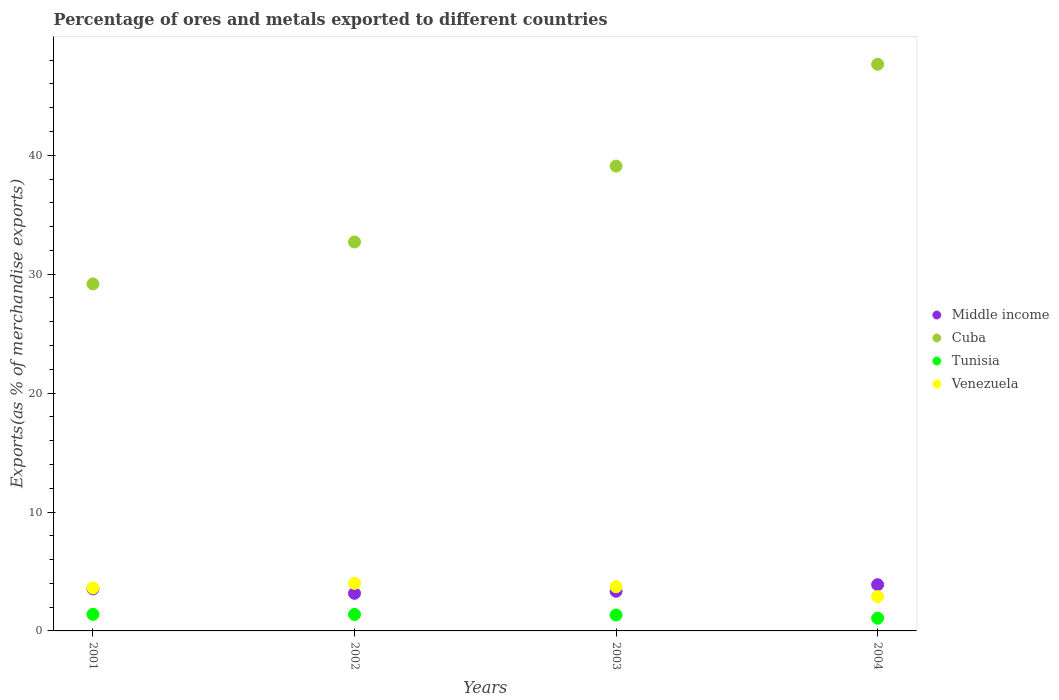How many different coloured dotlines are there?
Keep it short and to the point. 4. What is the percentage of exports to different countries in Middle income in 2001?
Offer a very short reply. 3.53. Across all years, what is the maximum percentage of exports to different countries in Cuba?
Ensure brevity in your answer.  47.66. Across all years, what is the minimum percentage of exports to different countries in Cuba?
Your response must be concise. 29.18. In which year was the percentage of exports to different countries in Tunisia maximum?
Your answer should be compact. 2001. What is the total percentage of exports to different countries in Venezuela in the graph?
Provide a succinct answer. 14.22. What is the difference between the percentage of exports to different countries in Middle income in 2002 and that in 2003?
Your answer should be very brief. -0.17. What is the difference between the percentage of exports to different countries in Cuba in 2002 and the percentage of exports to different countries in Tunisia in 2001?
Give a very brief answer. 31.32. What is the average percentage of exports to different countries in Venezuela per year?
Provide a succinct answer. 3.55. In the year 2003, what is the difference between the percentage of exports to different countries in Cuba and percentage of exports to different countries in Tunisia?
Offer a very short reply. 37.75. In how many years, is the percentage of exports to different countries in Middle income greater than 12 %?
Keep it short and to the point. 0. What is the ratio of the percentage of exports to different countries in Tunisia in 2001 to that in 2004?
Make the answer very short. 1.3. Is the difference between the percentage of exports to different countries in Cuba in 2001 and 2003 greater than the difference between the percentage of exports to different countries in Tunisia in 2001 and 2003?
Provide a short and direct response. No. What is the difference between the highest and the second highest percentage of exports to different countries in Cuba?
Keep it short and to the point. 8.56. What is the difference between the highest and the lowest percentage of exports to different countries in Venezuela?
Your answer should be compact. 1.11. In how many years, is the percentage of exports to different countries in Tunisia greater than the average percentage of exports to different countries in Tunisia taken over all years?
Your answer should be compact. 3. Is the percentage of exports to different countries in Cuba strictly greater than the percentage of exports to different countries in Tunisia over the years?
Offer a very short reply. Yes. Is the percentage of exports to different countries in Cuba strictly less than the percentage of exports to different countries in Middle income over the years?
Provide a succinct answer. No. How many dotlines are there?
Provide a succinct answer. 4. How many years are there in the graph?
Give a very brief answer. 4. Are the values on the major ticks of Y-axis written in scientific E-notation?
Provide a succinct answer. No. Does the graph contain grids?
Keep it short and to the point. No. Where does the legend appear in the graph?
Make the answer very short. Center right. How are the legend labels stacked?
Offer a very short reply. Vertical. What is the title of the graph?
Provide a short and direct response. Percentage of ores and metals exported to different countries. What is the label or title of the X-axis?
Ensure brevity in your answer.  Years. What is the label or title of the Y-axis?
Your answer should be very brief. Exports(as % of merchandise exports). What is the Exports(as % of merchandise exports) of Middle income in 2001?
Your answer should be compact. 3.53. What is the Exports(as % of merchandise exports) in Cuba in 2001?
Offer a very short reply. 29.18. What is the Exports(as % of merchandise exports) of Tunisia in 2001?
Ensure brevity in your answer.  1.39. What is the Exports(as % of merchandise exports) of Venezuela in 2001?
Keep it short and to the point. 3.61. What is the Exports(as % of merchandise exports) in Middle income in 2002?
Give a very brief answer. 3.16. What is the Exports(as % of merchandise exports) in Cuba in 2002?
Offer a terse response. 32.71. What is the Exports(as % of merchandise exports) in Tunisia in 2002?
Provide a short and direct response. 1.39. What is the Exports(as % of merchandise exports) of Venezuela in 2002?
Give a very brief answer. 4. What is the Exports(as % of merchandise exports) of Middle income in 2003?
Ensure brevity in your answer.  3.33. What is the Exports(as % of merchandise exports) in Cuba in 2003?
Your response must be concise. 39.09. What is the Exports(as % of merchandise exports) in Tunisia in 2003?
Your response must be concise. 1.34. What is the Exports(as % of merchandise exports) in Venezuela in 2003?
Keep it short and to the point. 3.72. What is the Exports(as % of merchandise exports) in Middle income in 2004?
Your answer should be compact. 3.89. What is the Exports(as % of merchandise exports) of Cuba in 2004?
Keep it short and to the point. 47.66. What is the Exports(as % of merchandise exports) in Tunisia in 2004?
Ensure brevity in your answer.  1.07. What is the Exports(as % of merchandise exports) of Venezuela in 2004?
Offer a very short reply. 2.89. Across all years, what is the maximum Exports(as % of merchandise exports) of Middle income?
Your answer should be compact. 3.89. Across all years, what is the maximum Exports(as % of merchandise exports) of Cuba?
Your answer should be compact. 47.66. Across all years, what is the maximum Exports(as % of merchandise exports) in Tunisia?
Your response must be concise. 1.39. Across all years, what is the maximum Exports(as % of merchandise exports) of Venezuela?
Provide a succinct answer. 4. Across all years, what is the minimum Exports(as % of merchandise exports) of Middle income?
Your answer should be very brief. 3.16. Across all years, what is the minimum Exports(as % of merchandise exports) in Cuba?
Provide a short and direct response. 29.18. Across all years, what is the minimum Exports(as % of merchandise exports) of Tunisia?
Offer a terse response. 1.07. Across all years, what is the minimum Exports(as % of merchandise exports) in Venezuela?
Provide a succinct answer. 2.89. What is the total Exports(as % of merchandise exports) of Middle income in the graph?
Keep it short and to the point. 13.92. What is the total Exports(as % of merchandise exports) in Cuba in the graph?
Provide a succinct answer. 148.64. What is the total Exports(as % of merchandise exports) in Tunisia in the graph?
Give a very brief answer. 5.19. What is the total Exports(as % of merchandise exports) in Venezuela in the graph?
Make the answer very short. 14.22. What is the difference between the Exports(as % of merchandise exports) in Middle income in 2001 and that in 2002?
Give a very brief answer. 0.37. What is the difference between the Exports(as % of merchandise exports) in Cuba in 2001 and that in 2002?
Make the answer very short. -3.53. What is the difference between the Exports(as % of merchandise exports) in Tunisia in 2001 and that in 2002?
Provide a short and direct response. 0.01. What is the difference between the Exports(as % of merchandise exports) of Venezuela in 2001 and that in 2002?
Ensure brevity in your answer.  -0.39. What is the difference between the Exports(as % of merchandise exports) of Middle income in 2001 and that in 2003?
Offer a very short reply. 0.2. What is the difference between the Exports(as % of merchandise exports) in Cuba in 2001 and that in 2003?
Your response must be concise. -9.91. What is the difference between the Exports(as % of merchandise exports) of Tunisia in 2001 and that in 2003?
Offer a very short reply. 0.06. What is the difference between the Exports(as % of merchandise exports) in Venezuela in 2001 and that in 2003?
Make the answer very short. -0.1. What is the difference between the Exports(as % of merchandise exports) of Middle income in 2001 and that in 2004?
Your response must be concise. -0.36. What is the difference between the Exports(as % of merchandise exports) in Cuba in 2001 and that in 2004?
Give a very brief answer. -18.47. What is the difference between the Exports(as % of merchandise exports) in Tunisia in 2001 and that in 2004?
Provide a short and direct response. 0.32. What is the difference between the Exports(as % of merchandise exports) of Venezuela in 2001 and that in 2004?
Provide a short and direct response. 0.73. What is the difference between the Exports(as % of merchandise exports) of Middle income in 2002 and that in 2003?
Offer a very short reply. -0.17. What is the difference between the Exports(as % of merchandise exports) of Cuba in 2002 and that in 2003?
Provide a succinct answer. -6.38. What is the difference between the Exports(as % of merchandise exports) in Tunisia in 2002 and that in 2003?
Make the answer very short. 0.05. What is the difference between the Exports(as % of merchandise exports) of Venezuela in 2002 and that in 2003?
Provide a succinct answer. 0.28. What is the difference between the Exports(as % of merchandise exports) of Middle income in 2002 and that in 2004?
Keep it short and to the point. -0.73. What is the difference between the Exports(as % of merchandise exports) of Cuba in 2002 and that in 2004?
Ensure brevity in your answer.  -14.95. What is the difference between the Exports(as % of merchandise exports) in Tunisia in 2002 and that in 2004?
Keep it short and to the point. 0.32. What is the difference between the Exports(as % of merchandise exports) in Venezuela in 2002 and that in 2004?
Ensure brevity in your answer.  1.11. What is the difference between the Exports(as % of merchandise exports) in Middle income in 2003 and that in 2004?
Give a very brief answer. -0.56. What is the difference between the Exports(as % of merchandise exports) of Cuba in 2003 and that in 2004?
Ensure brevity in your answer.  -8.56. What is the difference between the Exports(as % of merchandise exports) of Tunisia in 2003 and that in 2004?
Your answer should be compact. 0.27. What is the difference between the Exports(as % of merchandise exports) in Venezuela in 2003 and that in 2004?
Make the answer very short. 0.83. What is the difference between the Exports(as % of merchandise exports) in Middle income in 2001 and the Exports(as % of merchandise exports) in Cuba in 2002?
Keep it short and to the point. -29.18. What is the difference between the Exports(as % of merchandise exports) in Middle income in 2001 and the Exports(as % of merchandise exports) in Tunisia in 2002?
Your response must be concise. 2.15. What is the difference between the Exports(as % of merchandise exports) of Middle income in 2001 and the Exports(as % of merchandise exports) of Venezuela in 2002?
Provide a succinct answer. -0.47. What is the difference between the Exports(as % of merchandise exports) in Cuba in 2001 and the Exports(as % of merchandise exports) in Tunisia in 2002?
Provide a short and direct response. 27.8. What is the difference between the Exports(as % of merchandise exports) of Cuba in 2001 and the Exports(as % of merchandise exports) of Venezuela in 2002?
Offer a very short reply. 25.18. What is the difference between the Exports(as % of merchandise exports) of Tunisia in 2001 and the Exports(as % of merchandise exports) of Venezuela in 2002?
Ensure brevity in your answer.  -2.61. What is the difference between the Exports(as % of merchandise exports) in Middle income in 2001 and the Exports(as % of merchandise exports) in Cuba in 2003?
Offer a very short reply. -35.56. What is the difference between the Exports(as % of merchandise exports) of Middle income in 2001 and the Exports(as % of merchandise exports) of Tunisia in 2003?
Offer a very short reply. 2.19. What is the difference between the Exports(as % of merchandise exports) of Middle income in 2001 and the Exports(as % of merchandise exports) of Venezuela in 2003?
Offer a very short reply. -0.18. What is the difference between the Exports(as % of merchandise exports) in Cuba in 2001 and the Exports(as % of merchandise exports) in Tunisia in 2003?
Your response must be concise. 27.84. What is the difference between the Exports(as % of merchandise exports) of Cuba in 2001 and the Exports(as % of merchandise exports) of Venezuela in 2003?
Give a very brief answer. 25.47. What is the difference between the Exports(as % of merchandise exports) in Tunisia in 2001 and the Exports(as % of merchandise exports) in Venezuela in 2003?
Provide a short and direct response. -2.32. What is the difference between the Exports(as % of merchandise exports) of Middle income in 2001 and the Exports(as % of merchandise exports) of Cuba in 2004?
Offer a terse response. -44.12. What is the difference between the Exports(as % of merchandise exports) in Middle income in 2001 and the Exports(as % of merchandise exports) in Tunisia in 2004?
Provide a short and direct response. 2.46. What is the difference between the Exports(as % of merchandise exports) in Middle income in 2001 and the Exports(as % of merchandise exports) in Venezuela in 2004?
Offer a terse response. 0.65. What is the difference between the Exports(as % of merchandise exports) of Cuba in 2001 and the Exports(as % of merchandise exports) of Tunisia in 2004?
Your response must be concise. 28.11. What is the difference between the Exports(as % of merchandise exports) of Cuba in 2001 and the Exports(as % of merchandise exports) of Venezuela in 2004?
Provide a short and direct response. 26.3. What is the difference between the Exports(as % of merchandise exports) in Tunisia in 2001 and the Exports(as % of merchandise exports) in Venezuela in 2004?
Offer a terse response. -1.49. What is the difference between the Exports(as % of merchandise exports) in Middle income in 2002 and the Exports(as % of merchandise exports) in Cuba in 2003?
Your answer should be very brief. -35.93. What is the difference between the Exports(as % of merchandise exports) in Middle income in 2002 and the Exports(as % of merchandise exports) in Tunisia in 2003?
Provide a succinct answer. 1.82. What is the difference between the Exports(as % of merchandise exports) of Middle income in 2002 and the Exports(as % of merchandise exports) of Venezuela in 2003?
Keep it short and to the point. -0.56. What is the difference between the Exports(as % of merchandise exports) in Cuba in 2002 and the Exports(as % of merchandise exports) in Tunisia in 2003?
Ensure brevity in your answer.  31.37. What is the difference between the Exports(as % of merchandise exports) of Cuba in 2002 and the Exports(as % of merchandise exports) of Venezuela in 2003?
Your answer should be very brief. 28.99. What is the difference between the Exports(as % of merchandise exports) in Tunisia in 2002 and the Exports(as % of merchandise exports) in Venezuela in 2003?
Your response must be concise. -2.33. What is the difference between the Exports(as % of merchandise exports) of Middle income in 2002 and the Exports(as % of merchandise exports) of Cuba in 2004?
Offer a terse response. -44.49. What is the difference between the Exports(as % of merchandise exports) in Middle income in 2002 and the Exports(as % of merchandise exports) in Tunisia in 2004?
Offer a very short reply. 2.09. What is the difference between the Exports(as % of merchandise exports) in Middle income in 2002 and the Exports(as % of merchandise exports) in Venezuela in 2004?
Make the answer very short. 0.27. What is the difference between the Exports(as % of merchandise exports) in Cuba in 2002 and the Exports(as % of merchandise exports) in Tunisia in 2004?
Provide a short and direct response. 31.64. What is the difference between the Exports(as % of merchandise exports) in Cuba in 2002 and the Exports(as % of merchandise exports) in Venezuela in 2004?
Your answer should be compact. 29.82. What is the difference between the Exports(as % of merchandise exports) in Tunisia in 2002 and the Exports(as % of merchandise exports) in Venezuela in 2004?
Offer a terse response. -1.5. What is the difference between the Exports(as % of merchandise exports) of Middle income in 2003 and the Exports(as % of merchandise exports) of Cuba in 2004?
Ensure brevity in your answer.  -44.32. What is the difference between the Exports(as % of merchandise exports) of Middle income in 2003 and the Exports(as % of merchandise exports) of Tunisia in 2004?
Provide a succinct answer. 2.26. What is the difference between the Exports(as % of merchandise exports) of Middle income in 2003 and the Exports(as % of merchandise exports) of Venezuela in 2004?
Offer a very short reply. 0.45. What is the difference between the Exports(as % of merchandise exports) in Cuba in 2003 and the Exports(as % of merchandise exports) in Tunisia in 2004?
Offer a terse response. 38.02. What is the difference between the Exports(as % of merchandise exports) of Cuba in 2003 and the Exports(as % of merchandise exports) of Venezuela in 2004?
Provide a short and direct response. 36.21. What is the difference between the Exports(as % of merchandise exports) of Tunisia in 2003 and the Exports(as % of merchandise exports) of Venezuela in 2004?
Offer a terse response. -1.55. What is the average Exports(as % of merchandise exports) in Middle income per year?
Offer a very short reply. 3.48. What is the average Exports(as % of merchandise exports) in Cuba per year?
Offer a very short reply. 37.16. What is the average Exports(as % of merchandise exports) in Tunisia per year?
Make the answer very short. 1.3. What is the average Exports(as % of merchandise exports) in Venezuela per year?
Offer a very short reply. 3.55. In the year 2001, what is the difference between the Exports(as % of merchandise exports) in Middle income and Exports(as % of merchandise exports) in Cuba?
Make the answer very short. -25.65. In the year 2001, what is the difference between the Exports(as % of merchandise exports) of Middle income and Exports(as % of merchandise exports) of Tunisia?
Offer a very short reply. 2.14. In the year 2001, what is the difference between the Exports(as % of merchandise exports) of Middle income and Exports(as % of merchandise exports) of Venezuela?
Provide a short and direct response. -0.08. In the year 2001, what is the difference between the Exports(as % of merchandise exports) in Cuba and Exports(as % of merchandise exports) in Tunisia?
Keep it short and to the point. 27.79. In the year 2001, what is the difference between the Exports(as % of merchandise exports) in Cuba and Exports(as % of merchandise exports) in Venezuela?
Make the answer very short. 25.57. In the year 2001, what is the difference between the Exports(as % of merchandise exports) of Tunisia and Exports(as % of merchandise exports) of Venezuela?
Provide a short and direct response. -2.22. In the year 2002, what is the difference between the Exports(as % of merchandise exports) of Middle income and Exports(as % of merchandise exports) of Cuba?
Make the answer very short. -29.55. In the year 2002, what is the difference between the Exports(as % of merchandise exports) in Middle income and Exports(as % of merchandise exports) in Tunisia?
Ensure brevity in your answer.  1.77. In the year 2002, what is the difference between the Exports(as % of merchandise exports) in Middle income and Exports(as % of merchandise exports) in Venezuela?
Make the answer very short. -0.84. In the year 2002, what is the difference between the Exports(as % of merchandise exports) in Cuba and Exports(as % of merchandise exports) in Tunisia?
Offer a terse response. 31.32. In the year 2002, what is the difference between the Exports(as % of merchandise exports) in Cuba and Exports(as % of merchandise exports) in Venezuela?
Your answer should be compact. 28.71. In the year 2002, what is the difference between the Exports(as % of merchandise exports) of Tunisia and Exports(as % of merchandise exports) of Venezuela?
Ensure brevity in your answer.  -2.61. In the year 2003, what is the difference between the Exports(as % of merchandise exports) in Middle income and Exports(as % of merchandise exports) in Cuba?
Provide a succinct answer. -35.76. In the year 2003, what is the difference between the Exports(as % of merchandise exports) in Middle income and Exports(as % of merchandise exports) in Tunisia?
Your answer should be compact. 1.99. In the year 2003, what is the difference between the Exports(as % of merchandise exports) in Middle income and Exports(as % of merchandise exports) in Venezuela?
Your answer should be compact. -0.38. In the year 2003, what is the difference between the Exports(as % of merchandise exports) of Cuba and Exports(as % of merchandise exports) of Tunisia?
Provide a short and direct response. 37.75. In the year 2003, what is the difference between the Exports(as % of merchandise exports) of Cuba and Exports(as % of merchandise exports) of Venezuela?
Ensure brevity in your answer.  35.38. In the year 2003, what is the difference between the Exports(as % of merchandise exports) of Tunisia and Exports(as % of merchandise exports) of Venezuela?
Give a very brief answer. -2.38. In the year 2004, what is the difference between the Exports(as % of merchandise exports) in Middle income and Exports(as % of merchandise exports) in Cuba?
Your answer should be very brief. -43.77. In the year 2004, what is the difference between the Exports(as % of merchandise exports) in Middle income and Exports(as % of merchandise exports) in Tunisia?
Your answer should be compact. 2.82. In the year 2004, what is the difference between the Exports(as % of merchandise exports) of Middle income and Exports(as % of merchandise exports) of Venezuela?
Ensure brevity in your answer.  1. In the year 2004, what is the difference between the Exports(as % of merchandise exports) of Cuba and Exports(as % of merchandise exports) of Tunisia?
Provide a short and direct response. 46.58. In the year 2004, what is the difference between the Exports(as % of merchandise exports) in Cuba and Exports(as % of merchandise exports) in Venezuela?
Provide a succinct answer. 44.77. In the year 2004, what is the difference between the Exports(as % of merchandise exports) of Tunisia and Exports(as % of merchandise exports) of Venezuela?
Offer a very short reply. -1.82. What is the ratio of the Exports(as % of merchandise exports) of Middle income in 2001 to that in 2002?
Offer a very short reply. 1.12. What is the ratio of the Exports(as % of merchandise exports) of Cuba in 2001 to that in 2002?
Provide a short and direct response. 0.89. What is the ratio of the Exports(as % of merchandise exports) of Tunisia in 2001 to that in 2002?
Keep it short and to the point. 1.01. What is the ratio of the Exports(as % of merchandise exports) in Venezuela in 2001 to that in 2002?
Your answer should be compact. 0.9. What is the ratio of the Exports(as % of merchandise exports) of Middle income in 2001 to that in 2003?
Keep it short and to the point. 1.06. What is the ratio of the Exports(as % of merchandise exports) of Cuba in 2001 to that in 2003?
Your response must be concise. 0.75. What is the ratio of the Exports(as % of merchandise exports) of Tunisia in 2001 to that in 2003?
Keep it short and to the point. 1.04. What is the ratio of the Exports(as % of merchandise exports) of Venezuela in 2001 to that in 2003?
Your answer should be compact. 0.97. What is the ratio of the Exports(as % of merchandise exports) in Middle income in 2001 to that in 2004?
Your response must be concise. 0.91. What is the ratio of the Exports(as % of merchandise exports) of Cuba in 2001 to that in 2004?
Offer a very short reply. 0.61. What is the ratio of the Exports(as % of merchandise exports) in Tunisia in 2001 to that in 2004?
Keep it short and to the point. 1.3. What is the ratio of the Exports(as % of merchandise exports) in Venezuela in 2001 to that in 2004?
Give a very brief answer. 1.25. What is the ratio of the Exports(as % of merchandise exports) of Middle income in 2002 to that in 2003?
Offer a very short reply. 0.95. What is the ratio of the Exports(as % of merchandise exports) in Cuba in 2002 to that in 2003?
Provide a short and direct response. 0.84. What is the ratio of the Exports(as % of merchandise exports) in Tunisia in 2002 to that in 2003?
Provide a succinct answer. 1.04. What is the ratio of the Exports(as % of merchandise exports) of Venezuela in 2002 to that in 2003?
Your response must be concise. 1.08. What is the ratio of the Exports(as % of merchandise exports) in Middle income in 2002 to that in 2004?
Provide a succinct answer. 0.81. What is the ratio of the Exports(as % of merchandise exports) in Cuba in 2002 to that in 2004?
Ensure brevity in your answer.  0.69. What is the ratio of the Exports(as % of merchandise exports) in Tunisia in 2002 to that in 2004?
Offer a terse response. 1.3. What is the ratio of the Exports(as % of merchandise exports) of Venezuela in 2002 to that in 2004?
Keep it short and to the point. 1.39. What is the ratio of the Exports(as % of merchandise exports) in Middle income in 2003 to that in 2004?
Your answer should be very brief. 0.86. What is the ratio of the Exports(as % of merchandise exports) in Cuba in 2003 to that in 2004?
Offer a very short reply. 0.82. What is the ratio of the Exports(as % of merchandise exports) in Tunisia in 2003 to that in 2004?
Your answer should be compact. 1.25. What is the ratio of the Exports(as % of merchandise exports) in Venezuela in 2003 to that in 2004?
Your response must be concise. 1.29. What is the difference between the highest and the second highest Exports(as % of merchandise exports) in Middle income?
Provide a succinct answer. 0.36. What is the difference between the highest and the second highest Exports(as % of merchandise exports) in Cuba?
Your answer should be very brief. 8.56. What is the difference between the highest and the second highest Exports(as % of merchandise exports) in Tunisia?
Your response must be concise. 0.01. What is the difference between the highest and the second highest Exports(as % of merchandise exports) of Venezuela?
Your answer should be compact. 0.28. What is the difference between the highest and the lowest Exports(as % of merchandise exports) of Middle income?
Your answer should be very brief. 0.73. What is the difference between the highest and the lowest Exports(as % of merchandise exports) in Cuba?
Keep it short and to the point. 18.47. What is the difference between the highest and the lowest Exports(as % of merchandise exports) in Tunisia?
Your answer should be compact. 0.32. What is the difference between the highest and the lowest Exports(as % of merchandise exports) in Venezuela?
Keep it short and to the point. 1.11. 